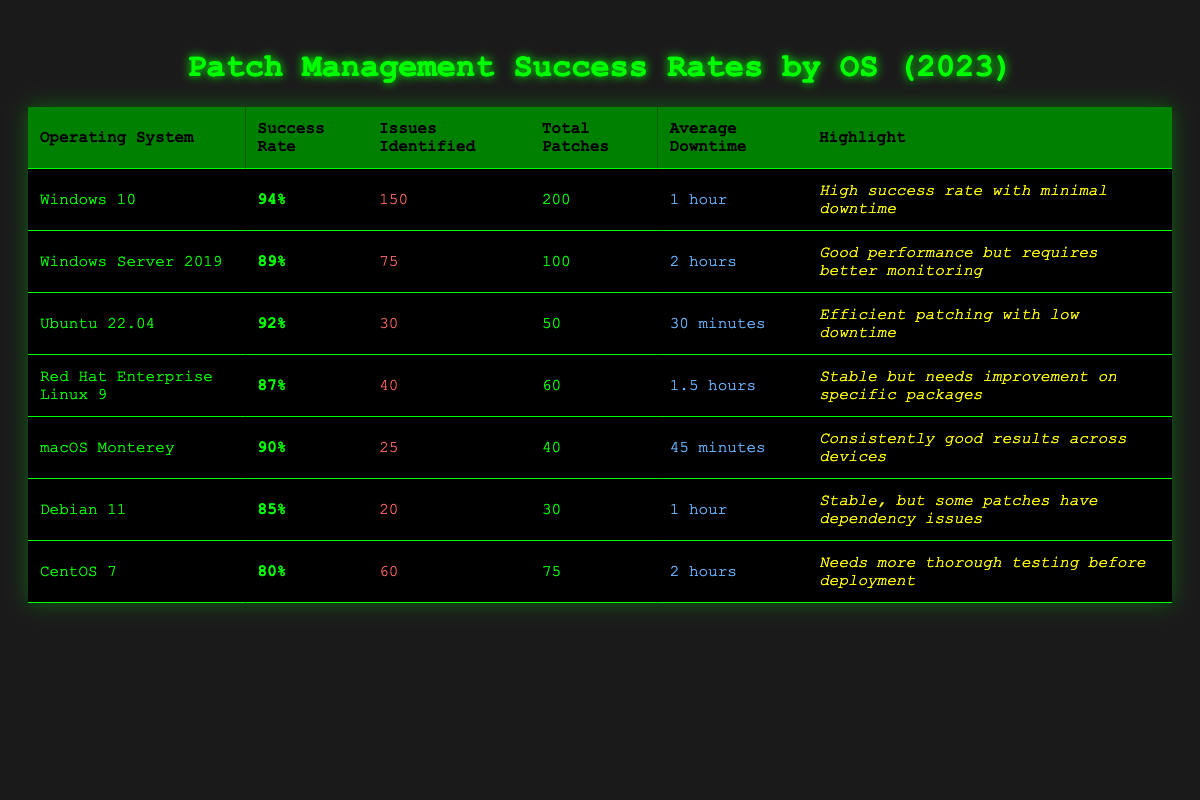What is the success rate of Windows 10? From the table, the success rate for Windows 10 is listed directly in the second column, showing a value of 94%.
Answer: 94% Which operating system has the highest success rate? By reviewing the success rates presented in the table, Windows 10 has the highest success rate at 94%.
Answer: Windows 10 What is the average downtime across all operating systems? The average downtime is calculated by converting the downtime into minutes. Windows 10 (60), Windows Server 2019 (120), Ubuntu 22.04 (30), Red Hat Enterprise Linux 9 (90), macOS Monterey (45), Debian 11 (60), and CentOS 7 (120). The total downtime is 525 minutes for 7 OS's, so the average is 525/7 = 75 minutes.
Answer: 75 minutes Did Ubuntu 22.04 have more issues identified than macOS Monterey? Looking at the table, Ubuntu 22.04 shows 30 issues identified, while macOS Monterey has 25. Since 30 is greater than 25, we conclude that Ubuntu 22.04 had more issues identified.
Answer: Yes How many total patches were applied to Red Hat Enterprise Linux 9 compared to Debian 11? Red Hat Enterprise Linux 9 had 60 total patches applied, while Debian 11 had 30. Comparing these values, 60 is greater than 30, indicating more patches for Red Hat than Debian.
Answer: Red Hat has more patches What is the difference in success rates between Windows Server 2019 and Red Hat Enterprise Linux 9? The success rate for Windows Server 2019 is 89%, and for Red Hat Enterprise Linux 9, it is 87%. The difference can be calculated as 89 - 87 = 2%. Thus, Windows Server 2019 has a 2% higher success rate compared to Red Hat.
Answer: 2% Is the average downtime for Ubuntu 22.04 less than the average downtime for Windows Server 2019? Ubuntu 22.04 has an average downtime of 30 minutes, while Windows Server 2019 has 2 hours (or 120 minutes). Since 30 is less than 120, it shows that Ubuntu has less downtime.
Answer: Yes Which OS has the least number of issues identified, and what is their success rate? The OS with the least issues identified is macOS Monterey, which has 25 issues. Its success rate is shown in the table as 90%.
Answer: macOS Monterey, 90% If you combine the issues identified from Debian 11 and CentOS 7, how many issues were found? Debian 11 has 20 issues identified, and CentOS 7 has 60. Adding these together gives 20 + 60 = 80 issues identified in total.
Answer: 80 issues Which operating systems have a success rate of 90% or higher? From the table, the operating systems with a success rate of 90% or higher are Windows 10 (94%), Ubuntu 22.04 (92%), and macOS Monterey (90%).
Answer: Windows 10, Ubuntu 22.04, macOS Monterey How many operating systems have an average downtime of less than 1 hour? The OSs with downtime less than 1 hour are Windows 10 (1 hour), Ubuntu 22.04 (30 minutes), and macOS Monterey (45 minutes). Thus, this accounts for 3 operating systems.
Answer: 3 operating systems 